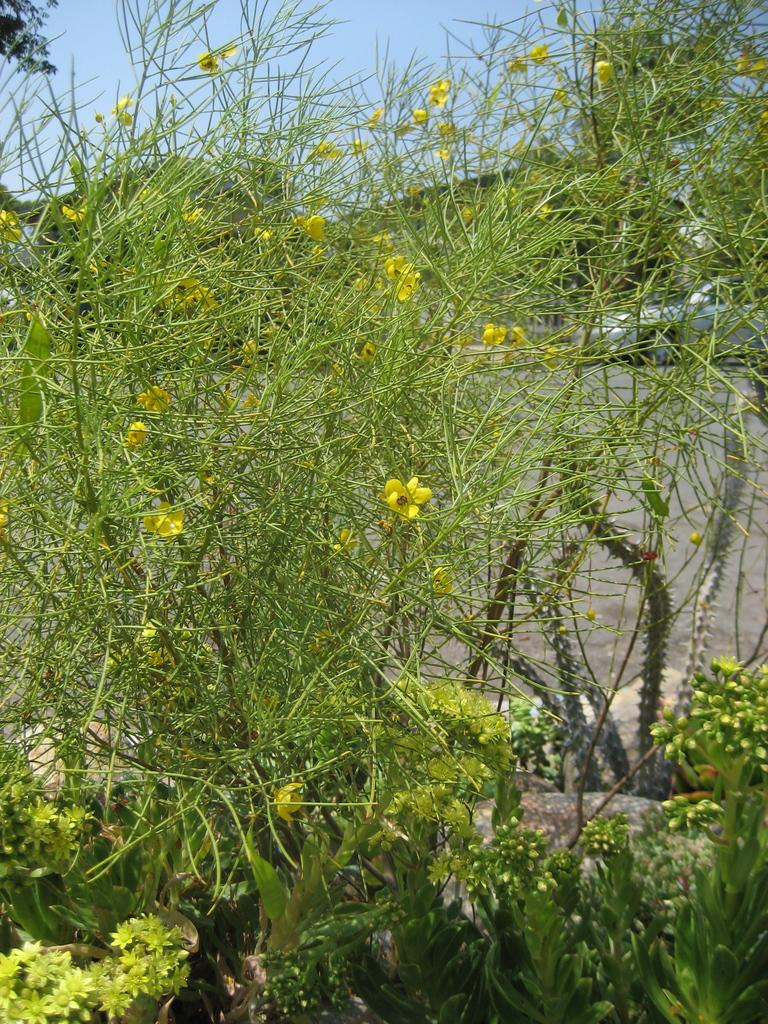What type of vegetation can be seen in the image? There are plants, trees, and flowers in the image. What else is visible in the image besides the vegetation? There is a vehicle visible on the road in the image. What can be seen in the sky in the image? The sky is visible in the image. What type of pain is the person experiencing in the image? There is no person present in the image, and therefore no indication of any pain being experienced. 